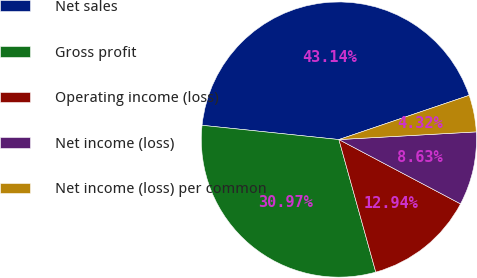Convert chart. <chart><loc_0><loc_0><loc_500><loc_500><pie_chart><fcel>Net sales<fcel>Gross profit<fcel>Operating income (loss)<fcel>Net income (loss)<fcel>Net income (loss) per common<nl><fcel>43.14%<fcel>30.97%<fcel>12.94%<fcel>8.63%<fcel>4.32%<nl></chart> 